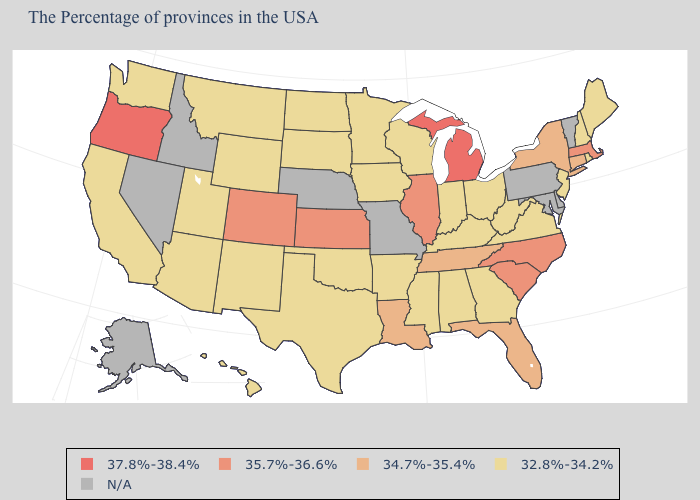What is the highest value in states that border Washington?
Short answer required. 37.8%-38.4%. Does North Dakota have the highest value in the MidWest?
Be succinct. No. What is the value of Washington?
Answer briefly. 32.8%-34.2%. What is the value of Montana?
Keep it brief. 32.8%-34.2%. Name the states that have a value in the range 37.8%-38.4%?
Be succinct. Michigan, Oregon. What is the lowest value in the USA?
Give a very brief answer. 32.8%-34.2%. Name the states that have a value in the range 34.7%-35.4%?
Keep it brief. Connecticut, New York, Florida, Tennessee, Louisiana. Name the states that have a value in the range 32.8%-34.2%?
Write a very short answer. Maine, Rhode Island, New Hampshire, New Jersey, Virginia, West Virginia, Ohio, Georgia, Kentucky, Indiana, Alabama, Wisconsin, Mississippi, Arkansas, Minnesota, Iowa, Oklahoma, Texas, South Dakota, North Dakota, Wyoming, New Mexico, Utah, Montana, Arizona, California, Washington, Hawaii. Name the states that have a value in the range 37.8%-38.4%?
Be succinct. Michigan, Oregon. How many symbols are there in the legend?
Give a very brief answer. 5. Which states have the highest value in the USA?
Give a very brief answer. Michigan, Oregon. Among the states that border Minnesota , which have the lowest value?
Be succinct. Wisconsin, Iowa, South Dakota, North Dakota. What is the value of Indiana?
Answer briefly. 32.8%-34.2%. Which states have the highest value in the USA?
Concise answer only. Michigan, Oregon. What is the value of West Virginia?
Be succinct. 32.8%-34.2%. 